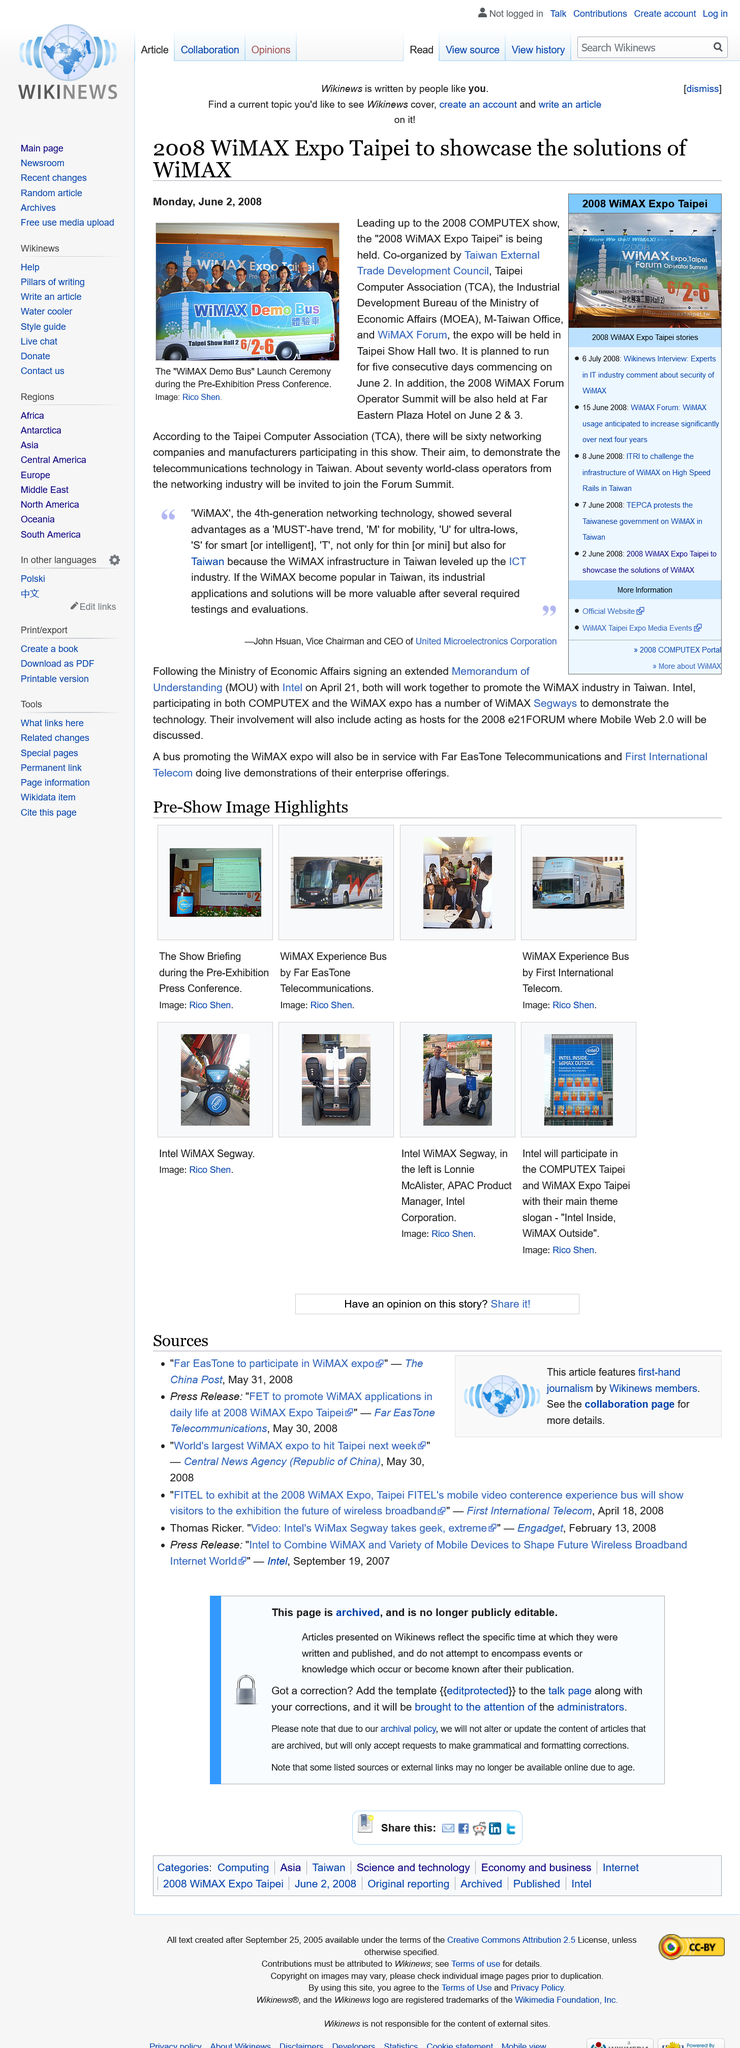Mention a couple of crucial points in this snapshot. The article on the 2008 WiMAX was published on Monday, June 2, 2008. The 2008 WiMAX Forum Operator Summit will be held at the Far Eastern Plaza Hotel. The acronym TCA stands for Taipei Computer Association, which is a well-known organization in the field of information technology. 